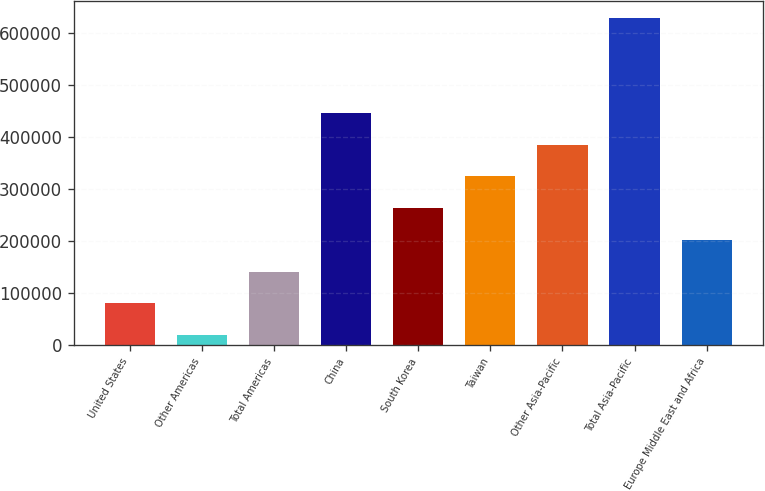Convert chart to OTSL. <chart><loc_0><loc_0><loc_500><loc_500><bar_chart><fcel>United States<fcel>Other Americas<fcel>Total Americas<fcel>China<fcel>South Korea<fcel>Taiwan<fcel>Other Asia-Pacific<fcel>Total Asia-Pacific<fcel>Europe Middle East and Africa<nl><fcel>79938.6<fcel>18925<fcel>140952<fcel>446020<fcel>262979<fcel>323993<fcel>385007<fcel>629061<fcel>201966<nl></chart> 